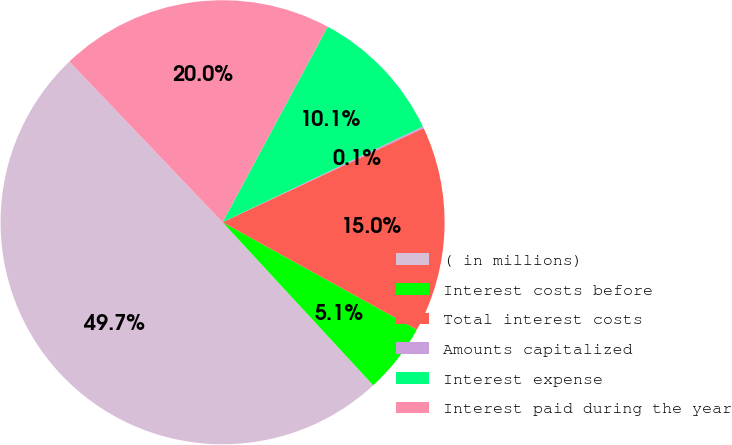<chart> <loc_0><loc_0><loc_500><loc_500><pie_chart><fcel>( in millions)<fcel>Interest costs before<fcel>Total interest costs<fcel>Amounts capitalized<fcel>Interest expense<fcel>Interest paid during the year<nl><fcel>49.74%<fcel>5.09%<fcel>15.01%<fcel>0.13%<fcel>10.05%<fcel>19.97%<nl></chart> 